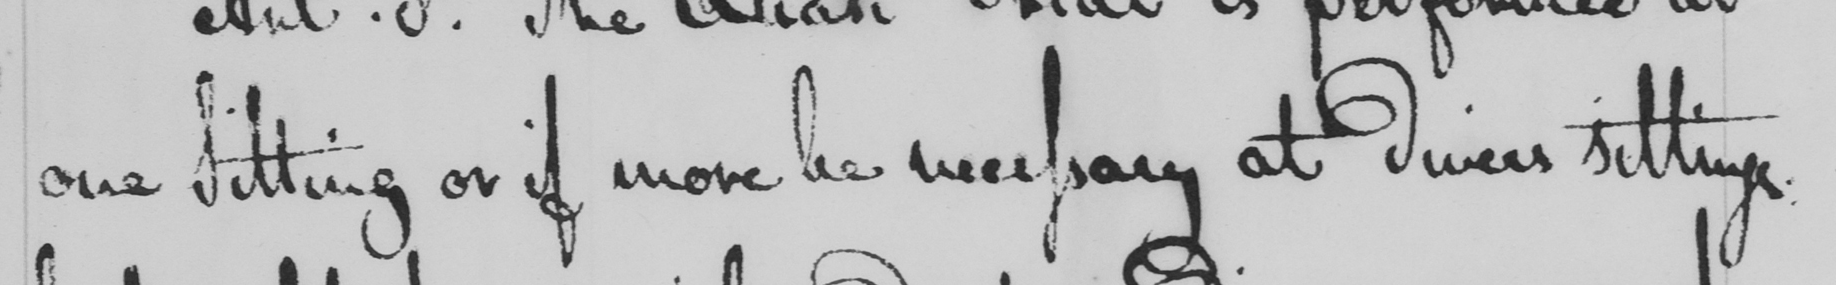Can you read and transcribe this handwriting? one Sitting or if more be necessary at divers sittings: 